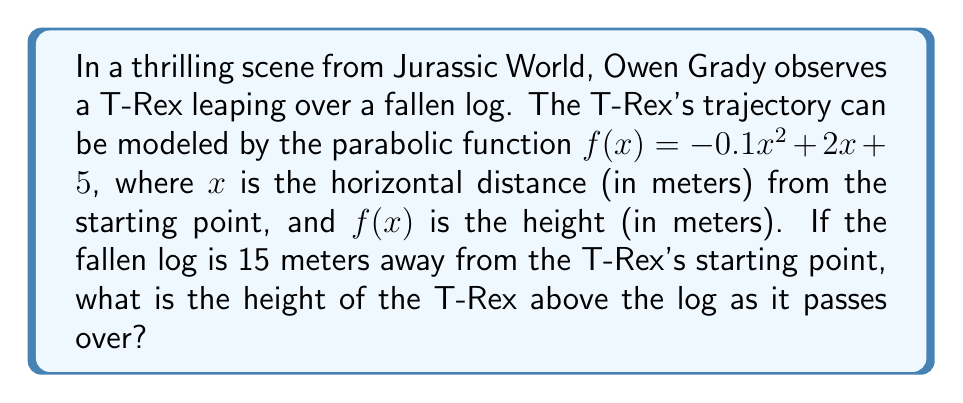Could you help me with this problem? Let's approach this step-by-step:

1) We're given the parabolic function: $f(x) = -0.1x^2 + 2x + 5$

2) We need to find the height when $x = 15$ (as the log is 15 meters away)

3) To find this, we simply substitute $x = 15$ into our function:

   $f(15) = -0.1(15)^2 + 2(15) + 5$

4) Let's calculate each term:
   - $-0.1(15)^2 = -0.1(225) = -22.5$
   - $2(15) = 30$
   - The constant term is already 5

5) Now, let's sum these terms:

   $f(15) = -22.5 + 30 + 5 = 12.5$

Therefore, when the T-Rex is directly above the log (15 meters from its starting point), it will be 12.5 meters high.
Answer: 12.5 meters 